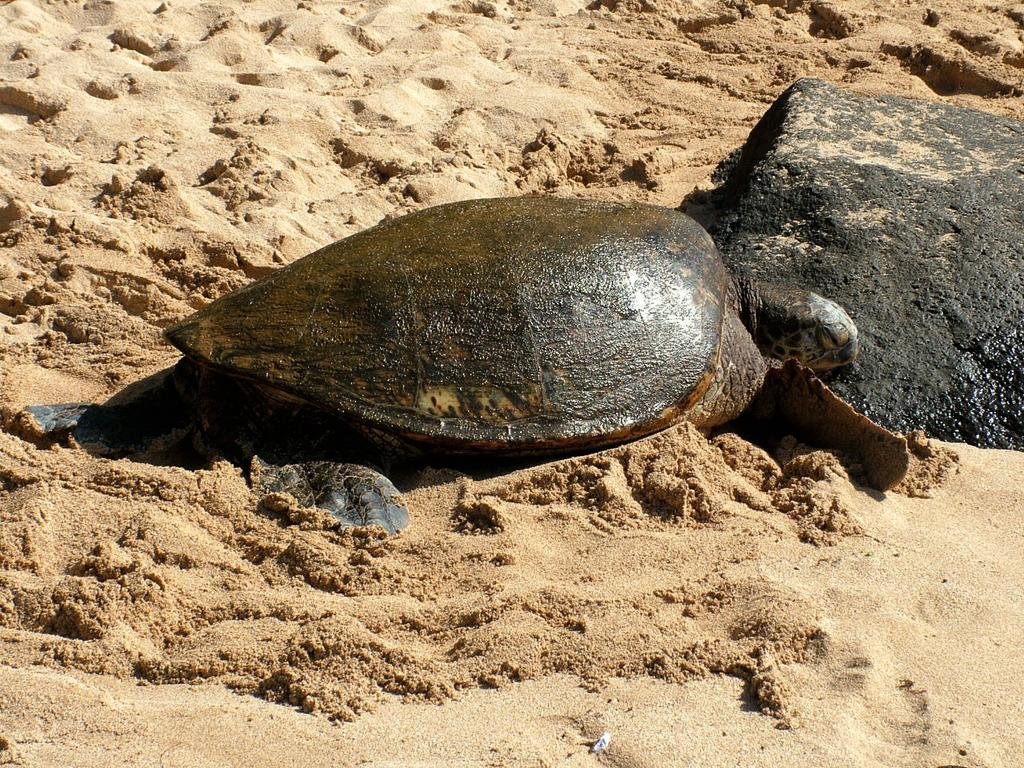What animal can be seen in the picture? There is a turtle in the picture. What type of terrain is visible at the bottom of the picture? There is sand at the bottom of the picture. What object can be seen on the right side of the picture? There is a rock on the right side of the picture. What type of wood is used to build the family's house in the picture? There is no house or wood present in the picture; it features a turtle, sand, and a rock. 